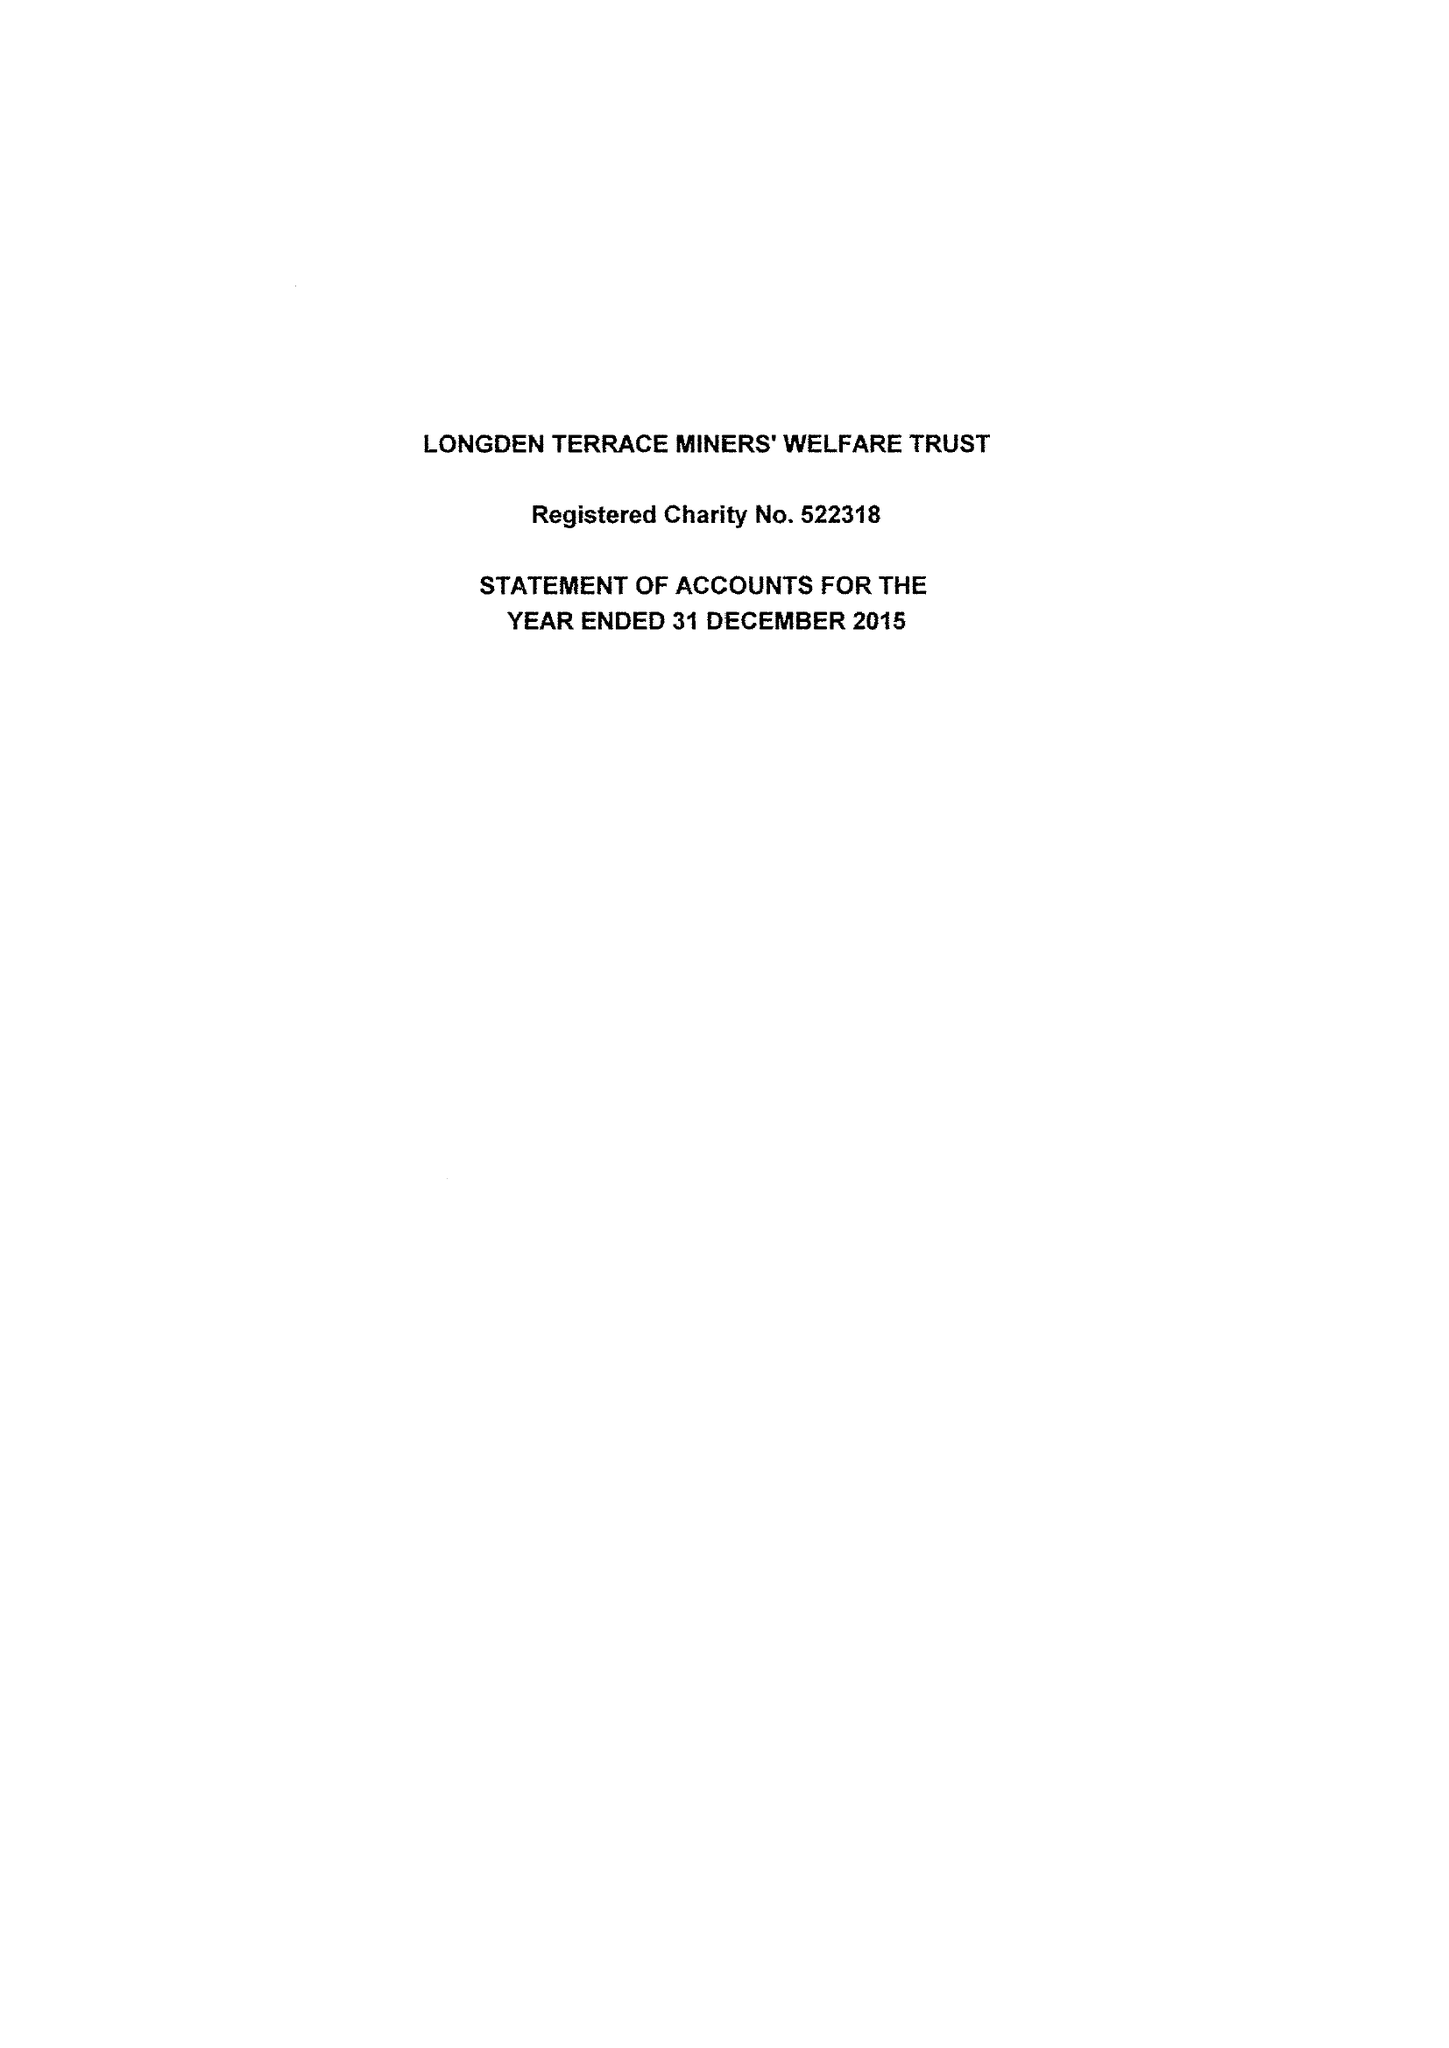What is the value for the charity_name?
Answer the question using a single word or phrase. Longden Terrace Miners' Welfare Trust 